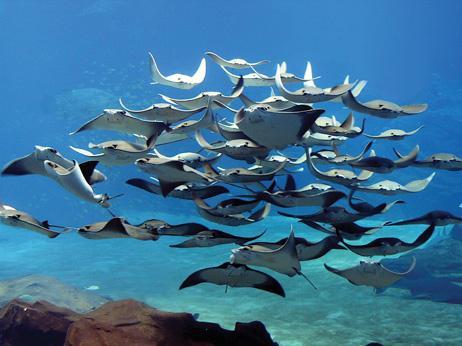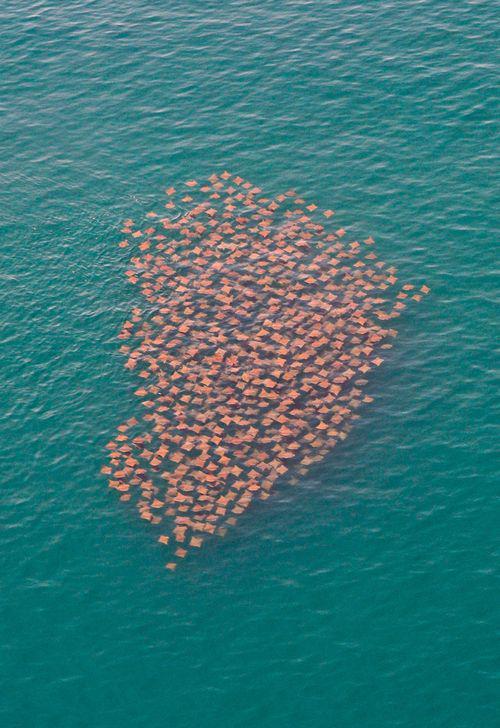The first image is the image on the left, the second image is the image on the right. Assess this claim about the two images: "One stingray is on the ocean floor.". Correct or not? Answer yes or no. No. The first image is the image on the left, the second image is the image on the right. Given the left and right images, does the statement "An image contains no more than three stingray in the foreground." hold true? Answer yes or no. No. 